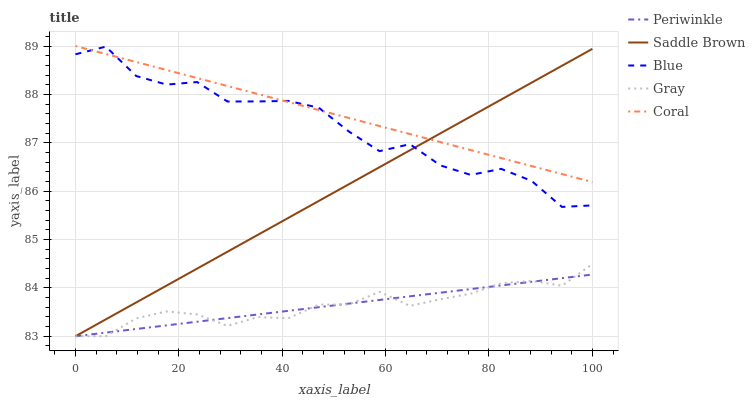Does Periwinkle have the minimum area under the curve?
Answer yes or no. Yes. Does Coral have the maximum area under the curve?
Answer yes or no. Yes. Does Gray have the minimum area under the curve?
Answer yes or no. No. Does Gray have the maximum area under the curve?
Answer yes or no. No. Is Coral the smoothest?
Answer yes or no. Yes. Is Blue the roughest?
Answer yes or no. Yes. Is Gray the smoothest?
Answer yes or no. No. Is Gray the roughest?
Answer yes or no. No. Does Coral have the lowest value?
Answer yes or no. No. Does Coral have the highest value?
Answer yes or no. Yes. Does Gray have the highest value?
Answer yes or no. No. Is Periwinkle less than Coral?
Answer yes or no. Yes. Is Coral greater than Gray?
Answer yes or no. Yes. Does Coral intersect Saddle Brown?
Answer yes or no. Yes. Is Coral less than Saddle Brown?
Answer yes or no. No. Is Coral greater than Saddle Brown?
Answer yes or no. No. Does Periwinkle intersect Coral?
Answer yes or no. No. 